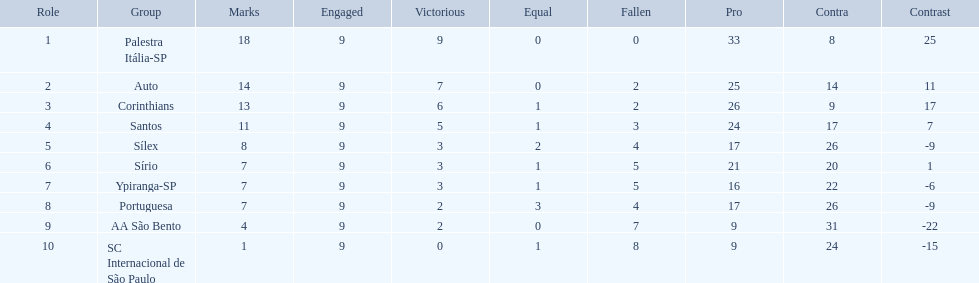Which team was the top scoring team? Palestra Itália-SP. 